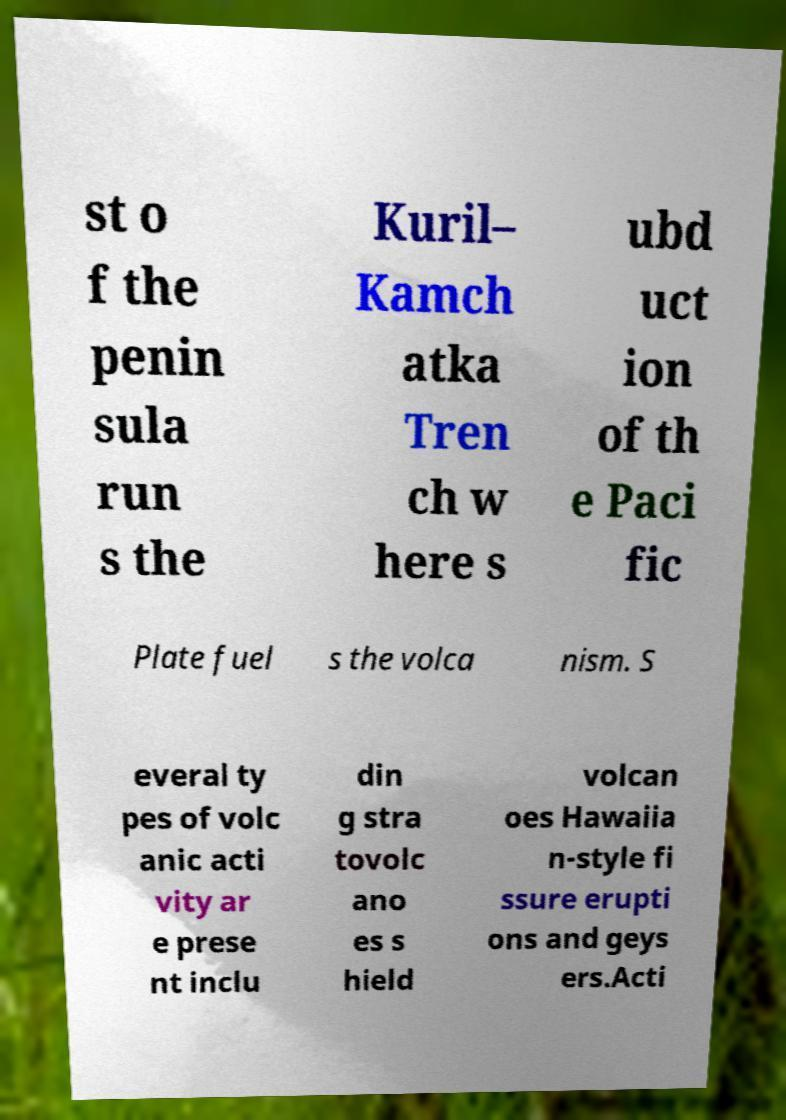Please read and relay the text visible in this image. What does it say? st o f the penin sula run s the Kuril– Kamch atka Tren ch w here s ubd uct ion of th e Paci fic Plate fuel s the volca nism. S everal ty pes of volc anic acti vity ar e prese nt inclu din g stra tovolc ano es s hield volcan oes Hawaiia n-style fi ssure erupti ons and geys ers.Acti 